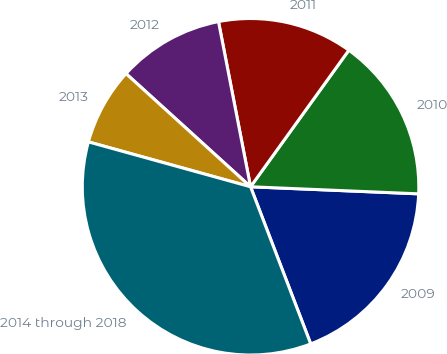Convert chart to OTSL. <chart><loc_0><loc_0><loc_500><loc_500><pie_chart><fcel>2009<fcel>2010<fcel>2011<fcel>2012<fcel>2013<fcel>2014 through 2018<nl><fcel>18.51%<fcel>15.74%<fcel>12.98%<fcel>10.21%<fcel>7.44%<fcel>35.12%<nl></chart> 